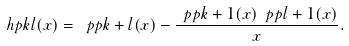Convert formula to latex. <formula><loc_0><loc_0><loc_500><loc_500>\ h p k l ( x ) = \ p p { k + l } ( x ) - \frac { \ p p { k + 1 } ( x ) \ p p { l + 1 } ( x ) } { x } .</formula> 